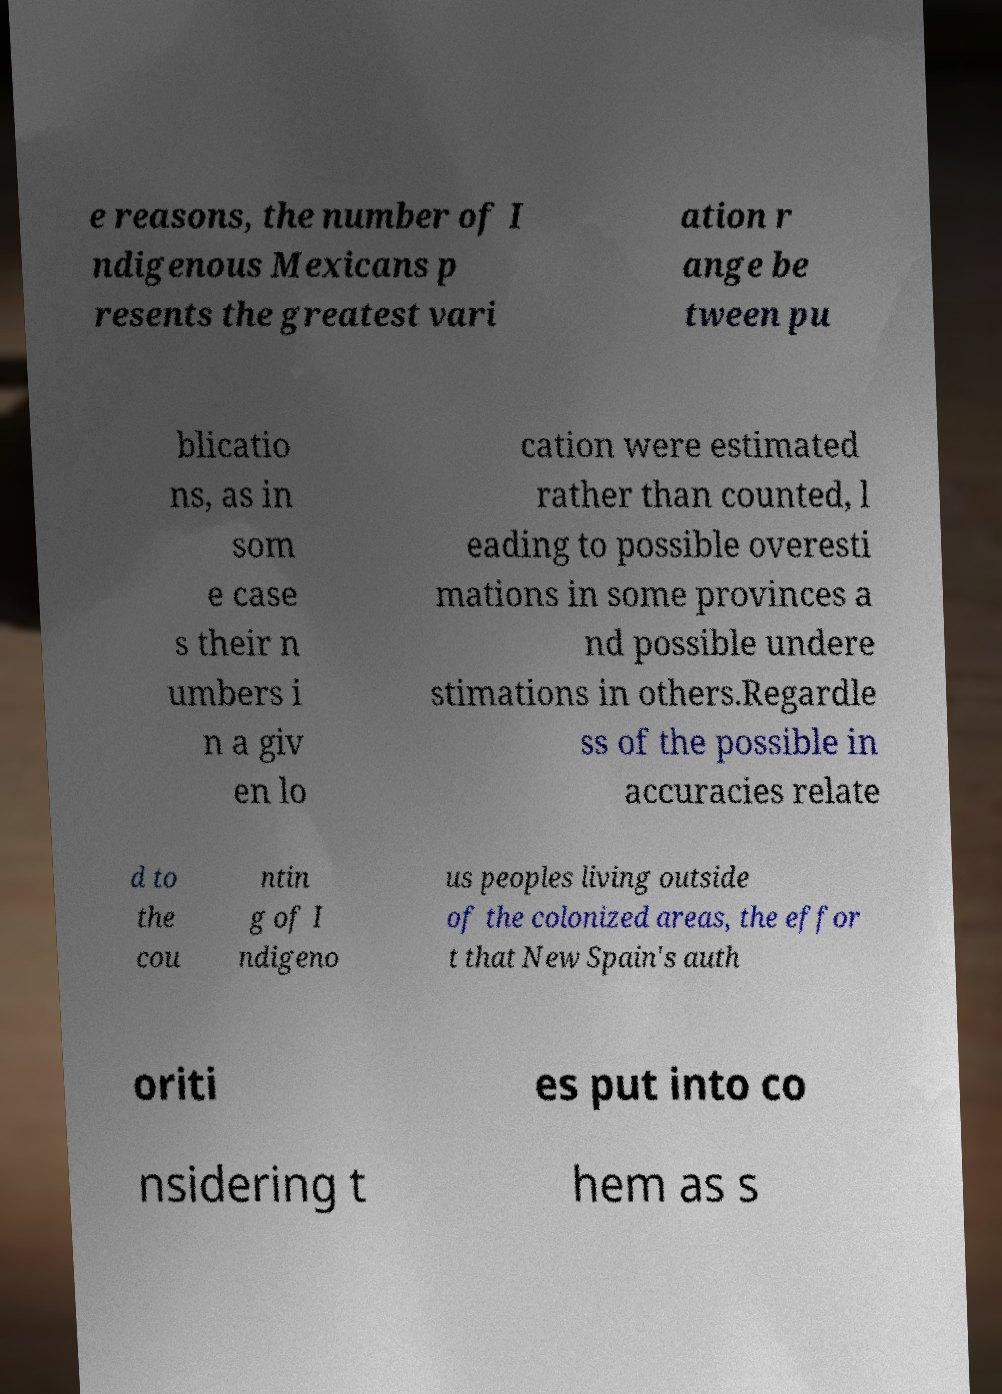For documentation purposes, I need the text within this image transcribed. Could you provide that? e reasons, the number of I ndigenous Mexicans p resents the greatest vari ation r ange be tween pu blicatio ns, as in som e case s their n umbers i n a giv en lo cation were estimated rather than counted, l eading to possible overesti mations in some provinces a nd possible undere stimations in others.Regardle ss of the possible in accuracies relate d to the cou ntin g of I ndigeno us peoples living outside of the colonized areas, the effor t that New Spain's auth oriti es put into co nsidering t hem as s 